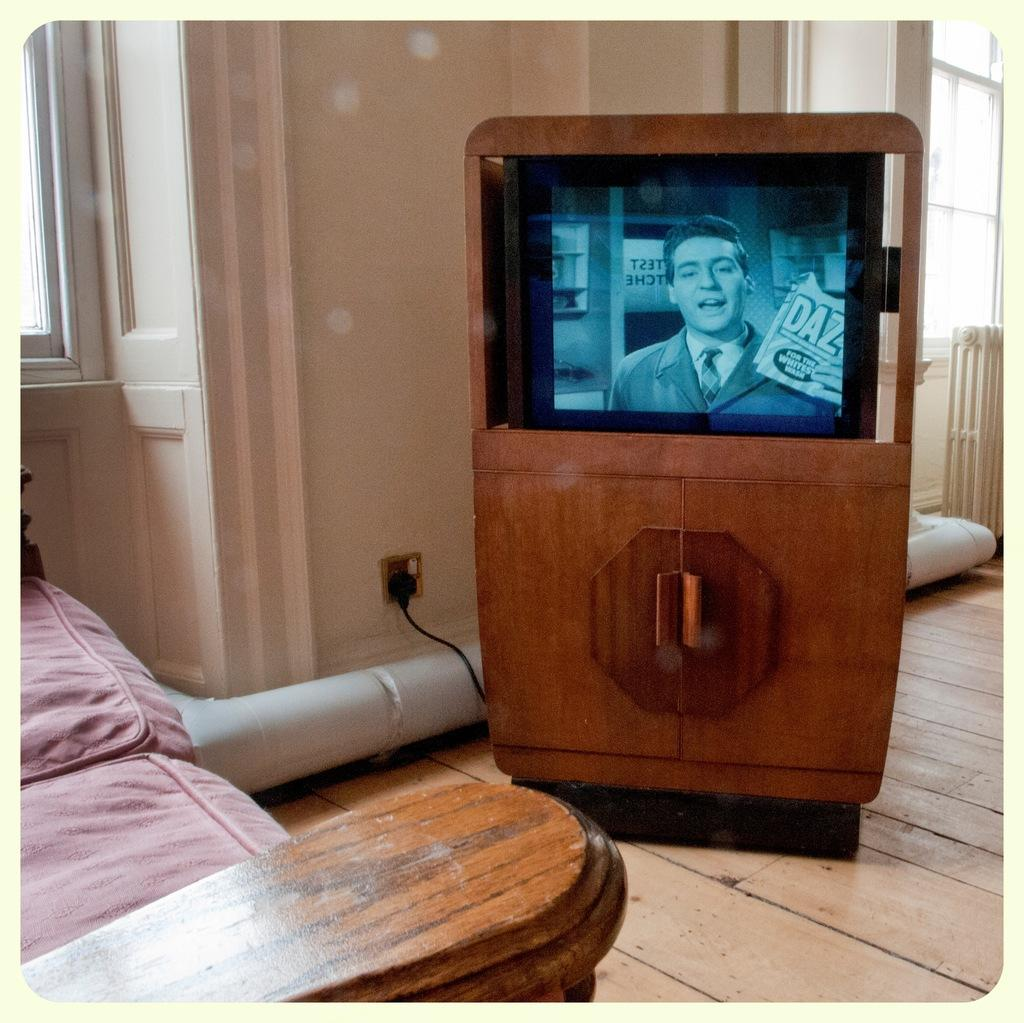What type of electronic device is present in the image? There is an old television set in the image. Where is the television set located? The television set is on the wooden floor. What type of knife is being used to set the rhythm in the image? There is no knife or rhythm present in the image; it only features an old television set on the wooden floor. 